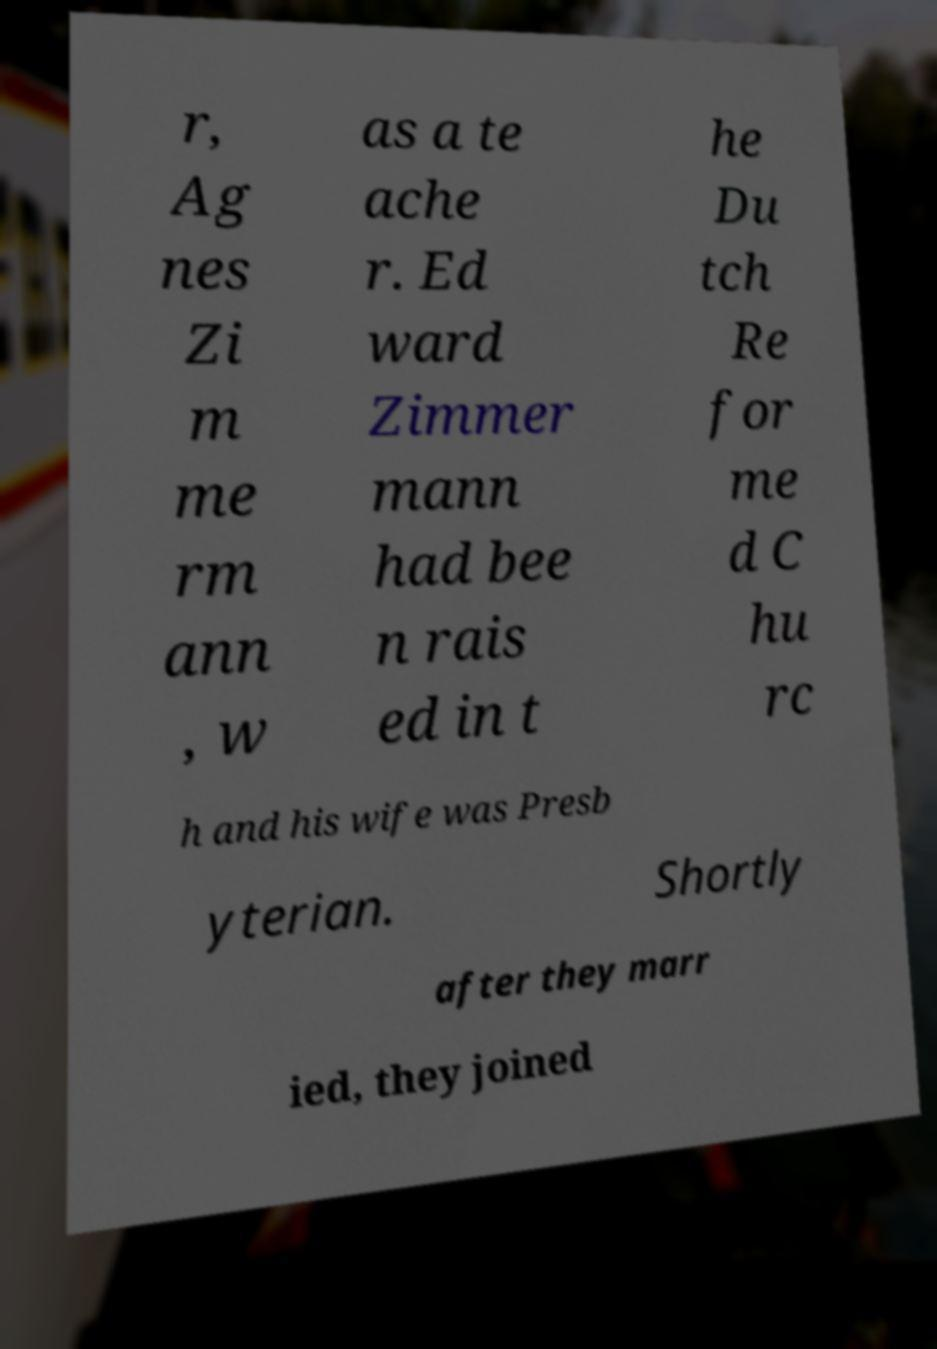What messages or text are displayed in this image? I need them in a readable, typed format. r, Ag nes Zi m me rm ann , w as a te ache r. Ed ward Zimmer mann had bee n rais ed in t he Du tch Re for me d C hu rc h and his wife was Presb yterian. Shortly after they marr ied, they joined 